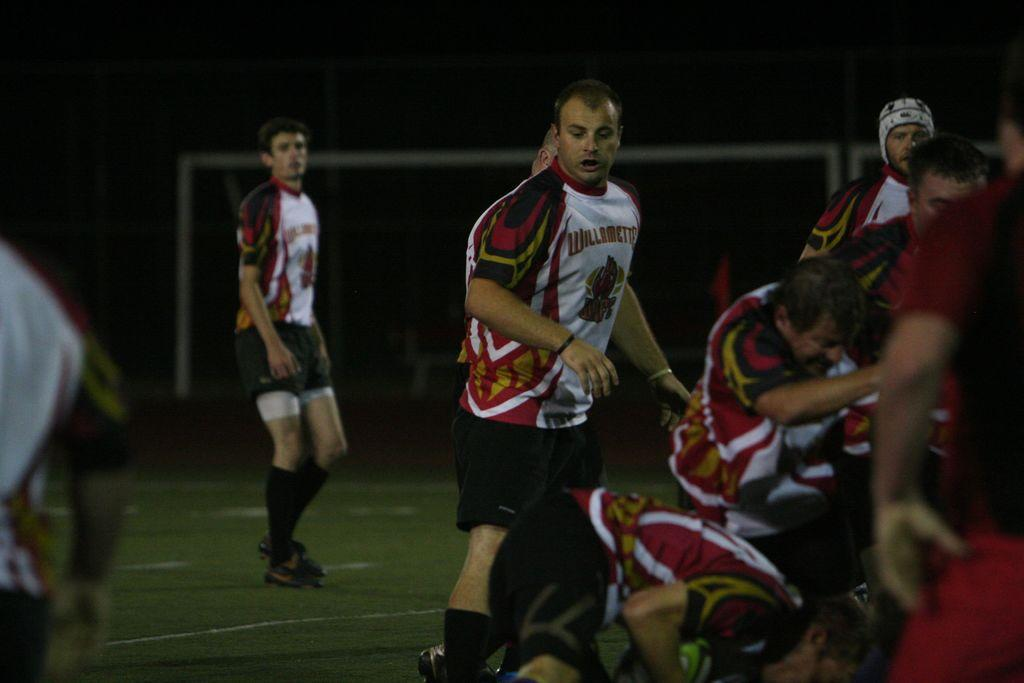<image>
Offer a succinct explanation of the picture presented. Players from the Willamette rugby team are playing on the field. 